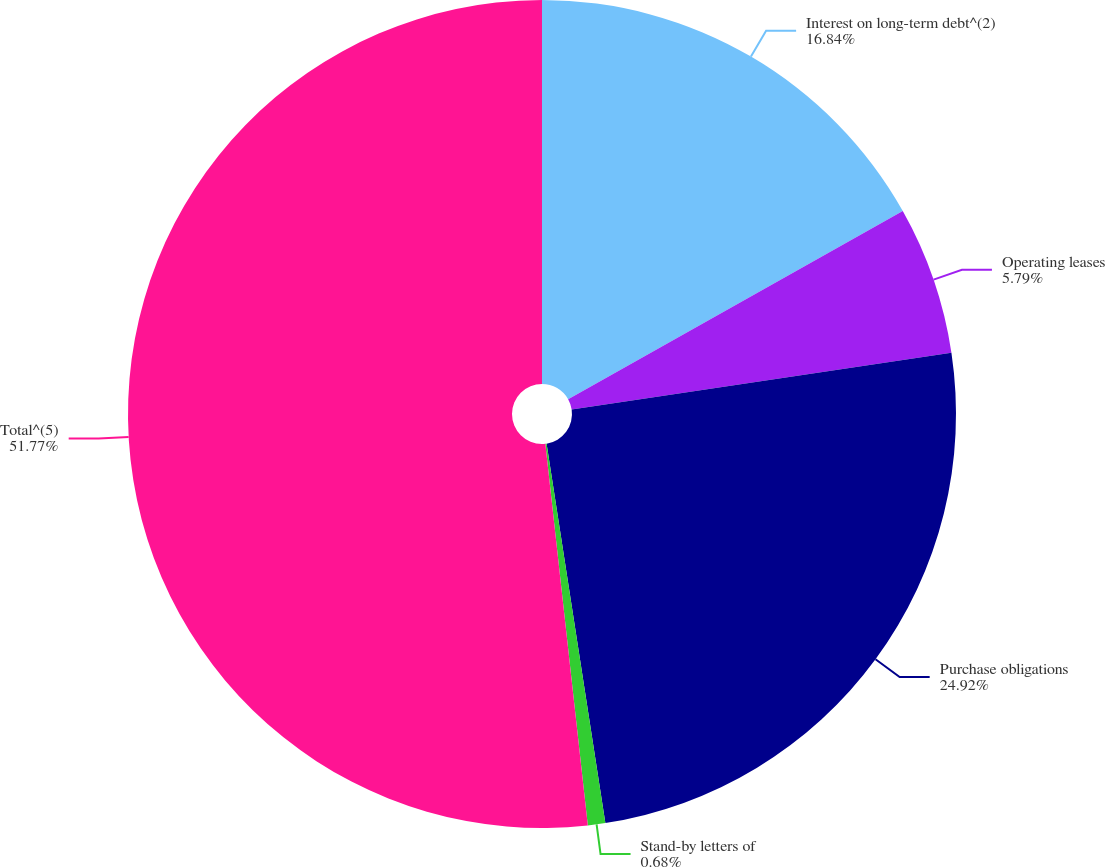Convert chart. <chart><loc_0><loc_0><loc_500><loc_500><pie_chart><fcel>Interest on long-term debt^(2)<fcel>Operating leases<fcel>Purchase obligations<fcel>Stand-by letters of<fcel>Total^(5)<nl><fcel>16.84%<fcel>5.79%<fcel>24.92%<fcel>0.68%<fcel>51.76%<nl></chart> 